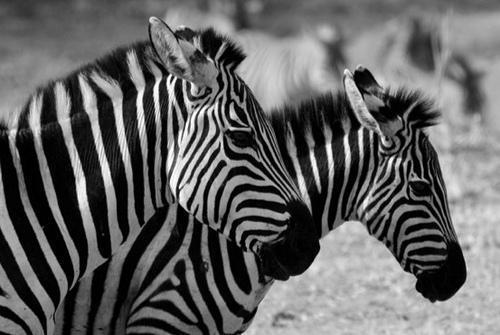How many zebras are pictured clearly?
Give a very brief answer. 2. How many eyes are visible?
Give a very brief answer. 2. 